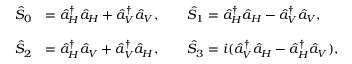Convert formula to latex. <formula><loc_0><loc_0><loc_500><loc_500>\begin{array} { r l } { \hat { S } _ { 0 } } & { = \hat { a } _ { H } ^ { \dagger } \hat { a } _ { H } + \hat { a } _ { V } ^ { \dagger } \hat { a } _ { V } , \quad \hat { S } _ { 1 } = \hat { a } _ { H } ^ { \dagger } \hat { a } _ { H } - \hat { a } _ { V } ^ { \dagger } \hat { a } _ { V } , } \\ \\ { \hat { S } _ { 2 } } & { = \hat { a } _ { H } ^ { \dagger } \hat { a } _ { V } + \hat { a } _ { V } ^ { \dagger } \hat { a } _ { H } , \quad \hat { S } _ { 3 } = i ( \hat { a } _ { V } ^ { \dagger } \hat { a } _ { H } - \hat { a } _ { H } ^ { \dagger } \hat { a } _ { V } ) , } \end{array}</formula> 